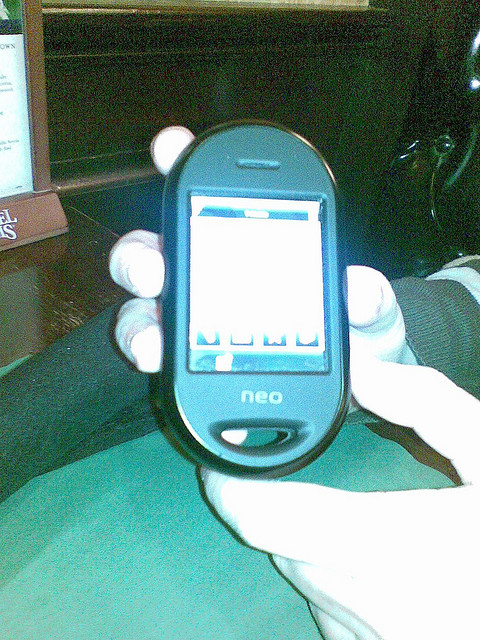Please transcribe the text in this image. neo 